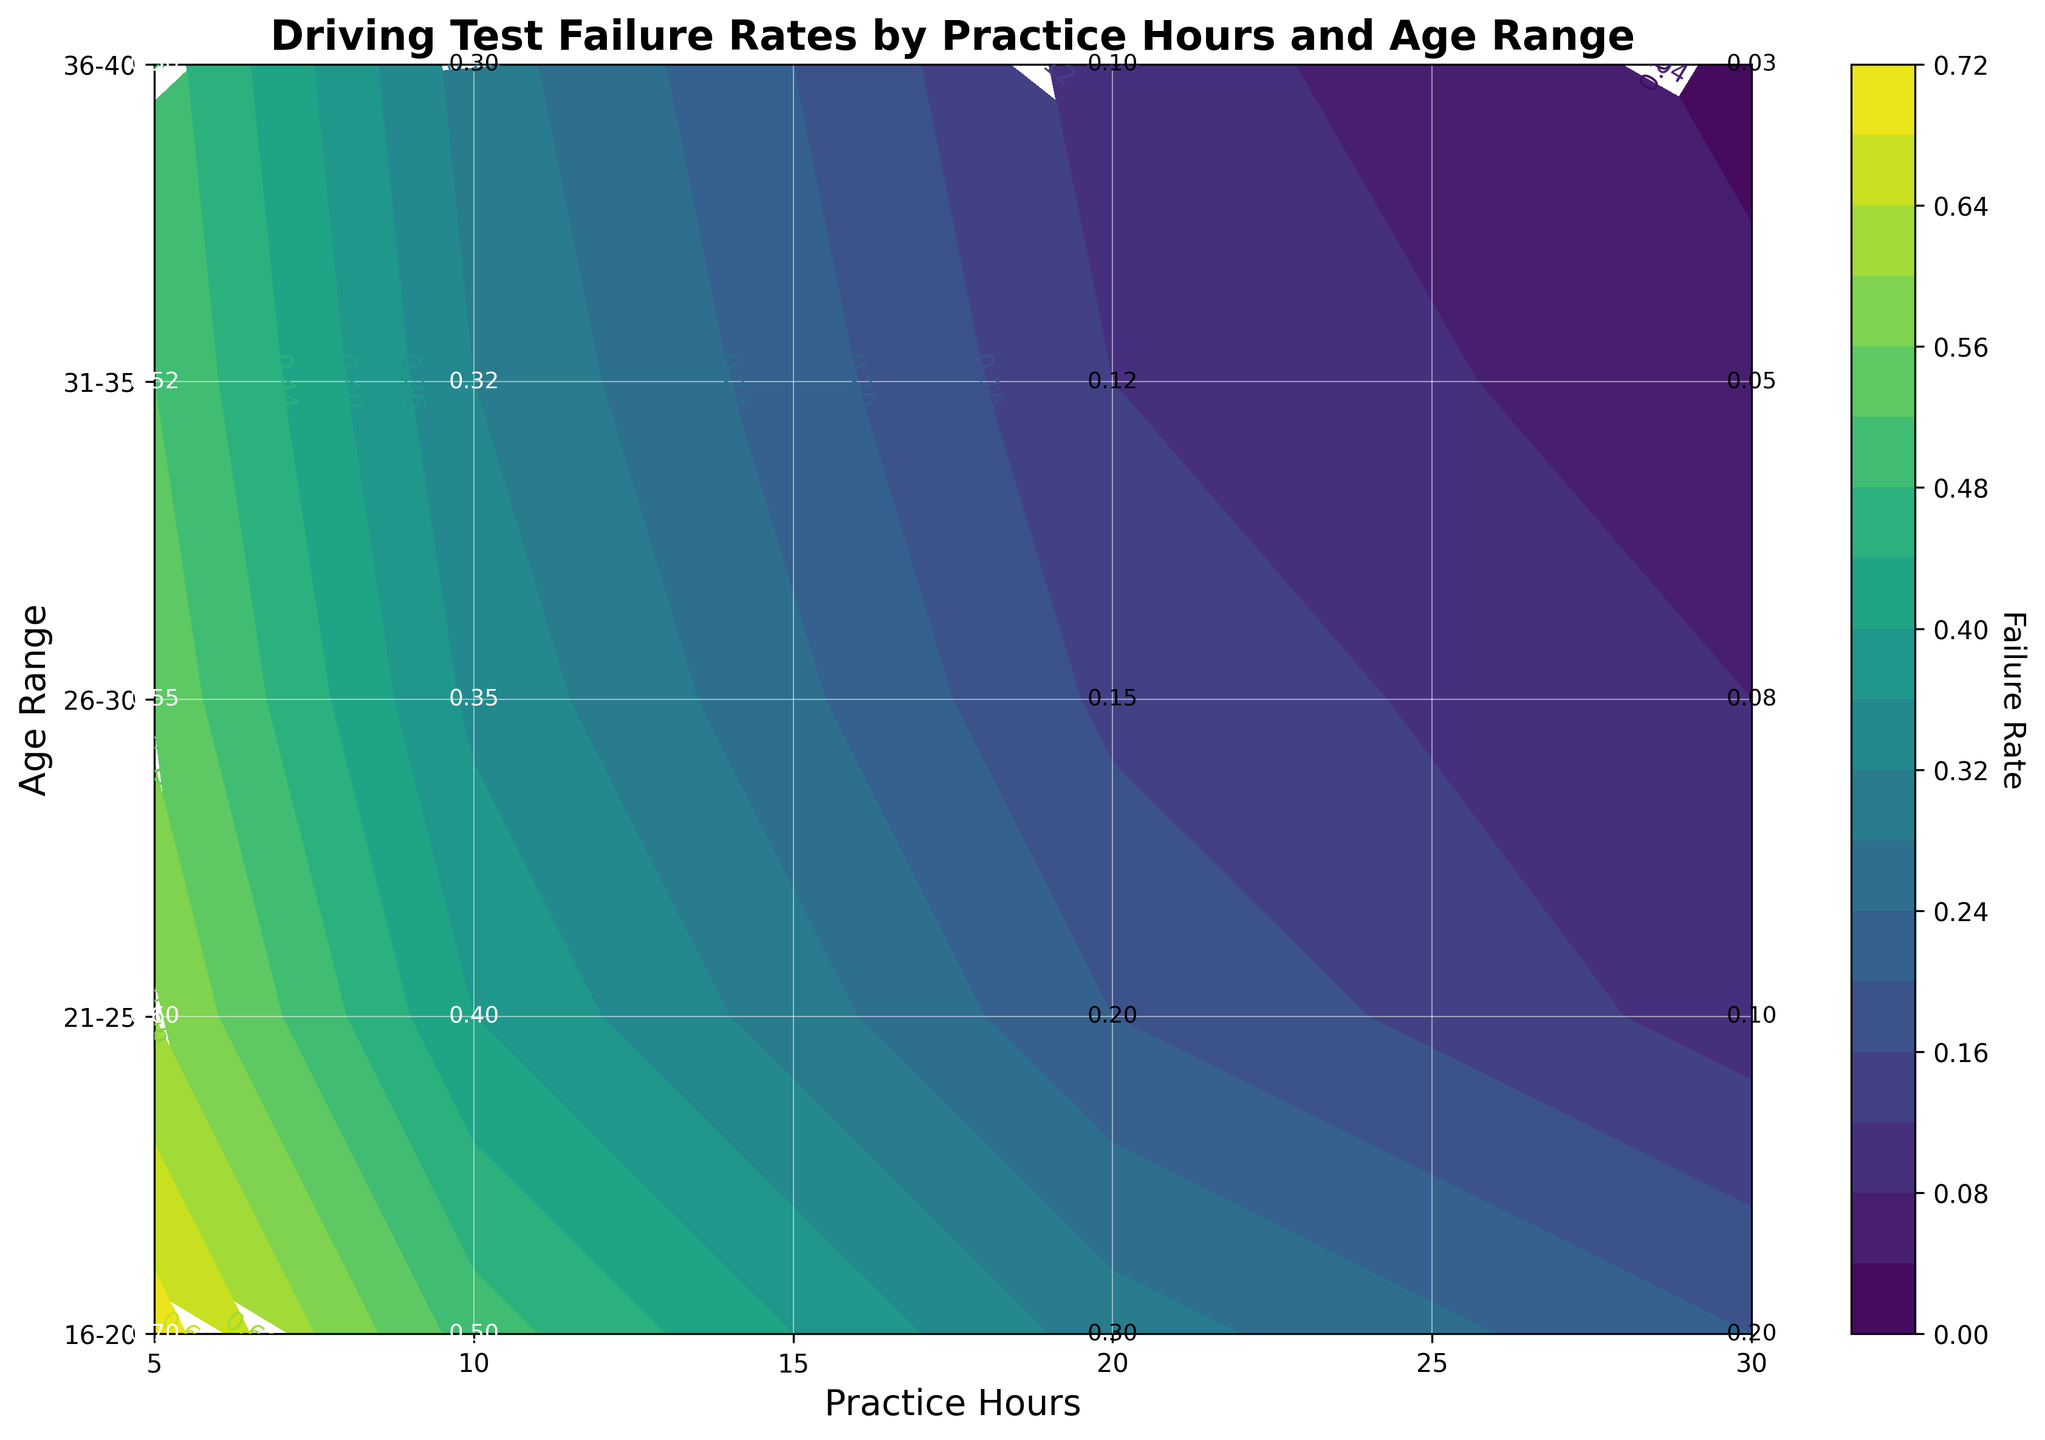What is the title of the plot? The title of the plot is shown at the top of the figure, which helps to quickly understand what the plot is about. In this case, the title indicates the relationship between driving test failure rates, practice hours, and age range.
Answer: Driving Test Failure Rates by Practice Hours and Age Range What is the failure rate for individuals aged 26-30 with 10 practice hours? Find the label for the age range 26-30 on the y-axis, trace horizontally to the tick labeled 10 on the x-axis, and read the value shown within the contour or text annotation.
Answer: 0.35 Which age range has the lowest failure rate with 30 practice hours? Compare the values at the 30 practice hours mark for each age range by following the annotations or contour lines. Identify which value is the lowest.
Answer: 36-40 How does the failure rate change for the age range 16-20 as practice hours increase from 5 to 30 hours? Identify the failure rate values for the age range 16-20 at 5, 10, 20, and 30 practice hours. Observe the trend of these values as practice hours increase.
Answer: It decreases from 0.70 to 0.20 What is the average failure rate for those aged 31-35 across all practice hours? Identify the failure rate values for the age range 31-35 at each practice hour: 5, 10, 20, and 30. Sum these values and divide by the number of data points (4) to find the average.
Answer: (0.52 + 0.32 + 0.12 + 0.05) / 4 = 0.2525 What practice hours setting shows the highest failure rate for any age range? Look for the highest value in the failure rate annotations or contours across all practice hours and age ranges.
Answer: 5 hours How does the failure rate for the age range 21-25 with 5 practice hours compare to the failure rate for the age range 31-35 with 10 practice hours? Identify the failure rate values for these specific scenarios and compare the two values to determine which is higher or if they are equal.
Answer: 0.60 (21-25, 5 hours) is higher than 0.32 (31-35, 10 hours) Which age group shows the least improvement in failure rate with increasing practice hours from 5 to 30 hours? Calculate the difference in failure rate between 5 and 30 practice hours for each age group. The group with the smallest difference shows the least improvement.
Answer: 16-20 